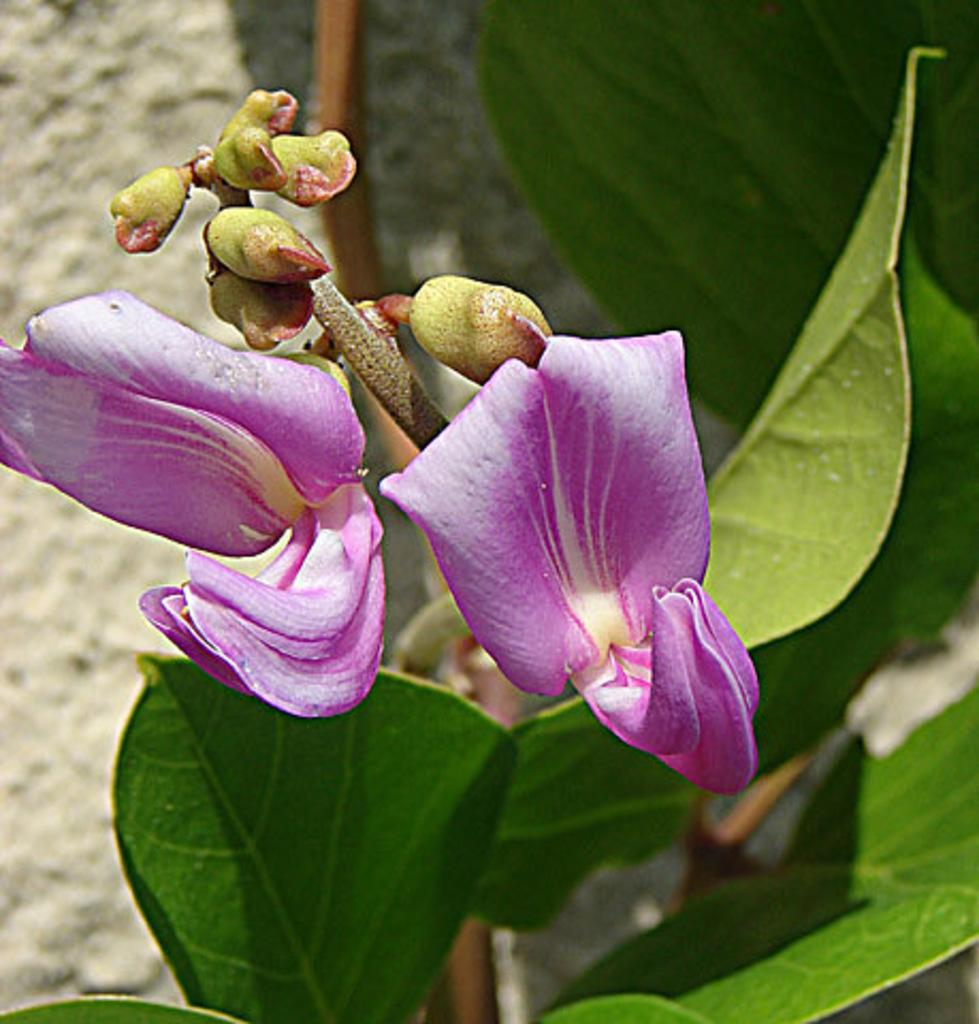What is the main subject in the foreground of the image? There is a flower in the foreground of the image. What can be seen in the background of the image? There is a plant in the background of the image. What type of knife is being used to compete in the gardening competition in the image? There is no knife or gardening competition present in the image; it features a flower in the foreground and a plant in the background. 